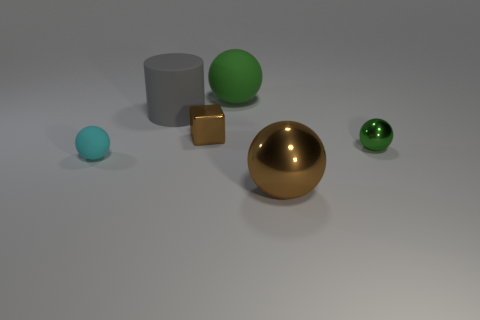Subtract 1 balls. How many balls are left? 3 Subtract all blue spheres. Subtract all gray blocks. How many spheres are left? 4 Add 3 large gray cylinders. How many objects exist? 9 Subtract all cylinders. How many objects are left? 5 Subtract all green spheres. Subtract all small matte objects. How many objects are left? 3 Add 3 cyan balls. How many cyan balls are left? 4 Add 1 brown objects. How many brown objects exist? 3 Subtract 0 gray balls. How many objects are left? 6 